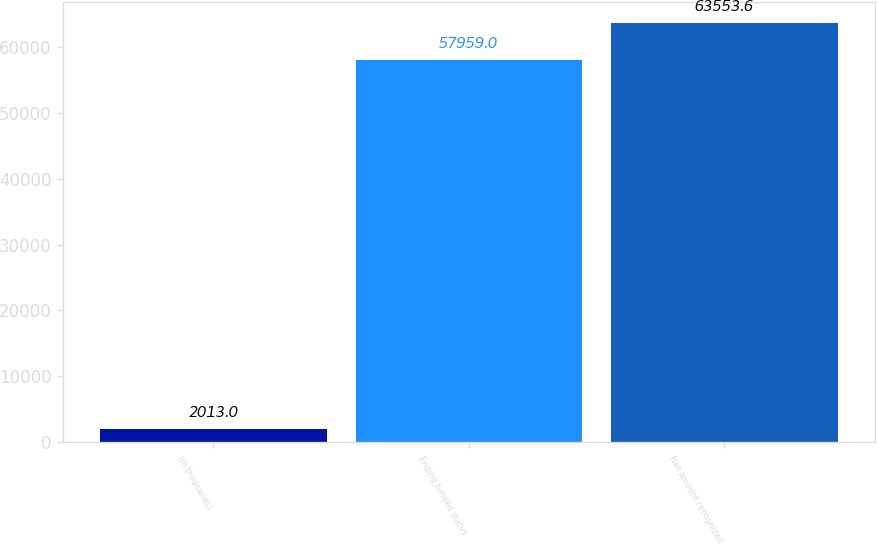Convert chart. <chart><loc_0><loc_0><loc_500><loc_500><bar_chart><fcel>(In thousands)<fcel>Ending funded status<fcel>Net amount recognized<nl><fcel>2013<fcel>57959<fcel>63553.6<nl></chart> 